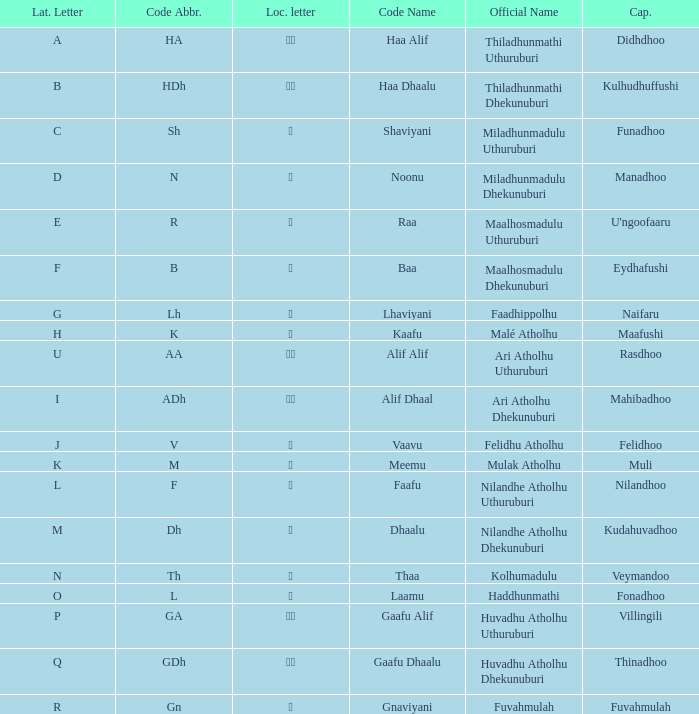The capital of funadhoo has what local letter? ށ. 